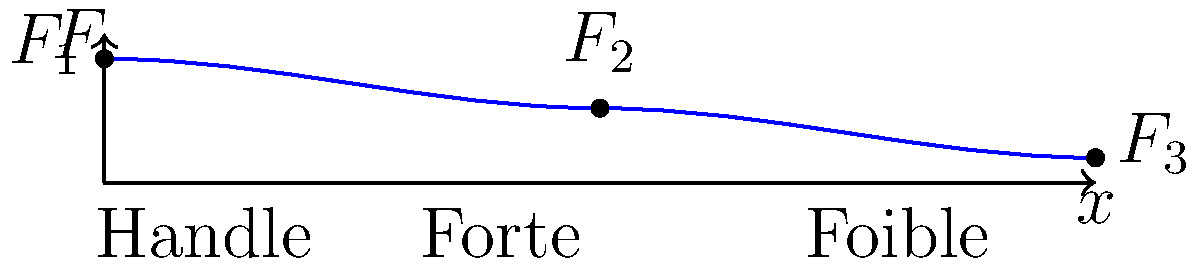During a lunge in fencing, the force distribution along the blade varies. The graph shows the force distribution on a fencing blade, where $F$ represents the force and $x$ represents the distance along the blade from the handle. If the total length of the blade is 90 cm and the forte region extends for 30 cm from the handle, calculate the approximate ratio of the force at the tip of the blade ($F_3$) to the force at the end of the forte region ($F_2$). To solve this problem, we'll follow these steps:

1. Identify the relevant points on the graph:
   - $F_1$: Force at the handle (x = 0 cm)
   - $F_2$: Force at the end of the forte (x = 30 cm)
   - $F_3$: Force at the tip of the blade (x = 90 cm)

2. Estimate the relative values of forces from the graph:
   - $F_1$ ≈ 25 units
   - $F_2$ ≈ 17 units
   - $F_3$ ≈ 5 units

3. Calculate the ratio of $F_3$ to $F_2$:
   $$\text{Ratio} = \frac{F_3}{F_2} = \frac{5}{17} \approx 0.294$$

4. Simplify the ratio:
   $$\frac{5}{17} \approx \frac{3}{10} = 0.3$$

Therefore, the approximate ratio of the force at the tip of the blade ($F_3$) to the force at the end of the forte region ($F_2$) is 3:10 or 0.3.
Answer: 3:10 or 0.3 